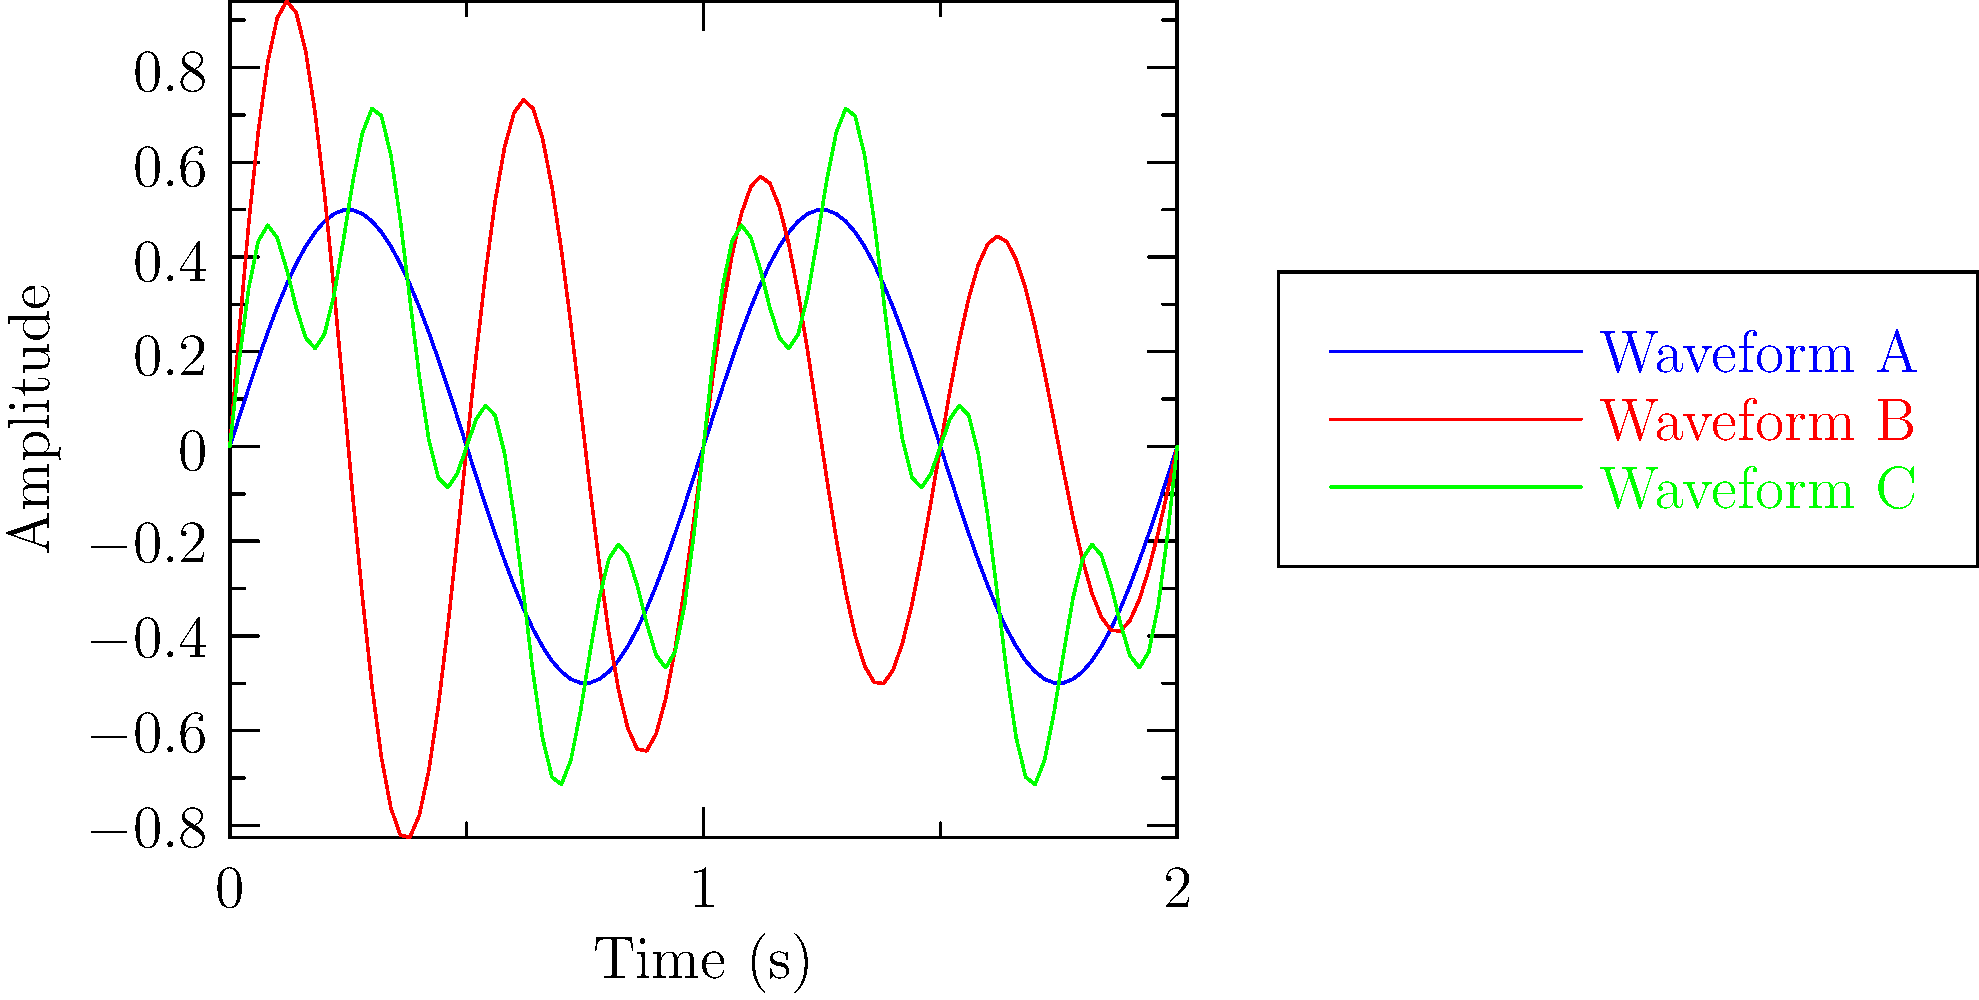As a retired film score composer for horror movies, analyze the three waveforms (A, B, and C) shown in the graph. Which waveform would be most effective for creating a suspenseful, gradually fading sound effect typically used in horror film scores? To answer this question, let's analyze each waveform:

1. Waveform A (blue):
   - Simple sinusoidal wave
   - Constant amplitude
   - Steady frequency

2. Waveform B (red):
   - Decaying sinusoidal wave
   - Amplitude decreases over time (envelope follows $e^{-x/2}$)
   - Higher frequency than Waveform A

3. Waveform C (green):
   - Complex waveform (sum of two sine waves)
   - Constant amplitude
   - Contains both low and high frequency components

For a suspenseful, gradually fading sound effect in horror films:

- We need a sound that diminishes over time to create tension
- A higher frequency can add to the sense of unease
- A simple waveform is often more effective for creating a clear, haunting tone

Waveform B best fits these criteria because:
1. It has a decaying amplitude, creating a fading effect
2. It has a higher frequency than Waveform A, adding to the tension
3. It's a simple waveform, which can produce a clear, eerie tone

Waveform A lacks the fading effect, and Waveform C, while complex, doesn't have the gradual fade needed for this particular effect.
Answer: Waveform B 